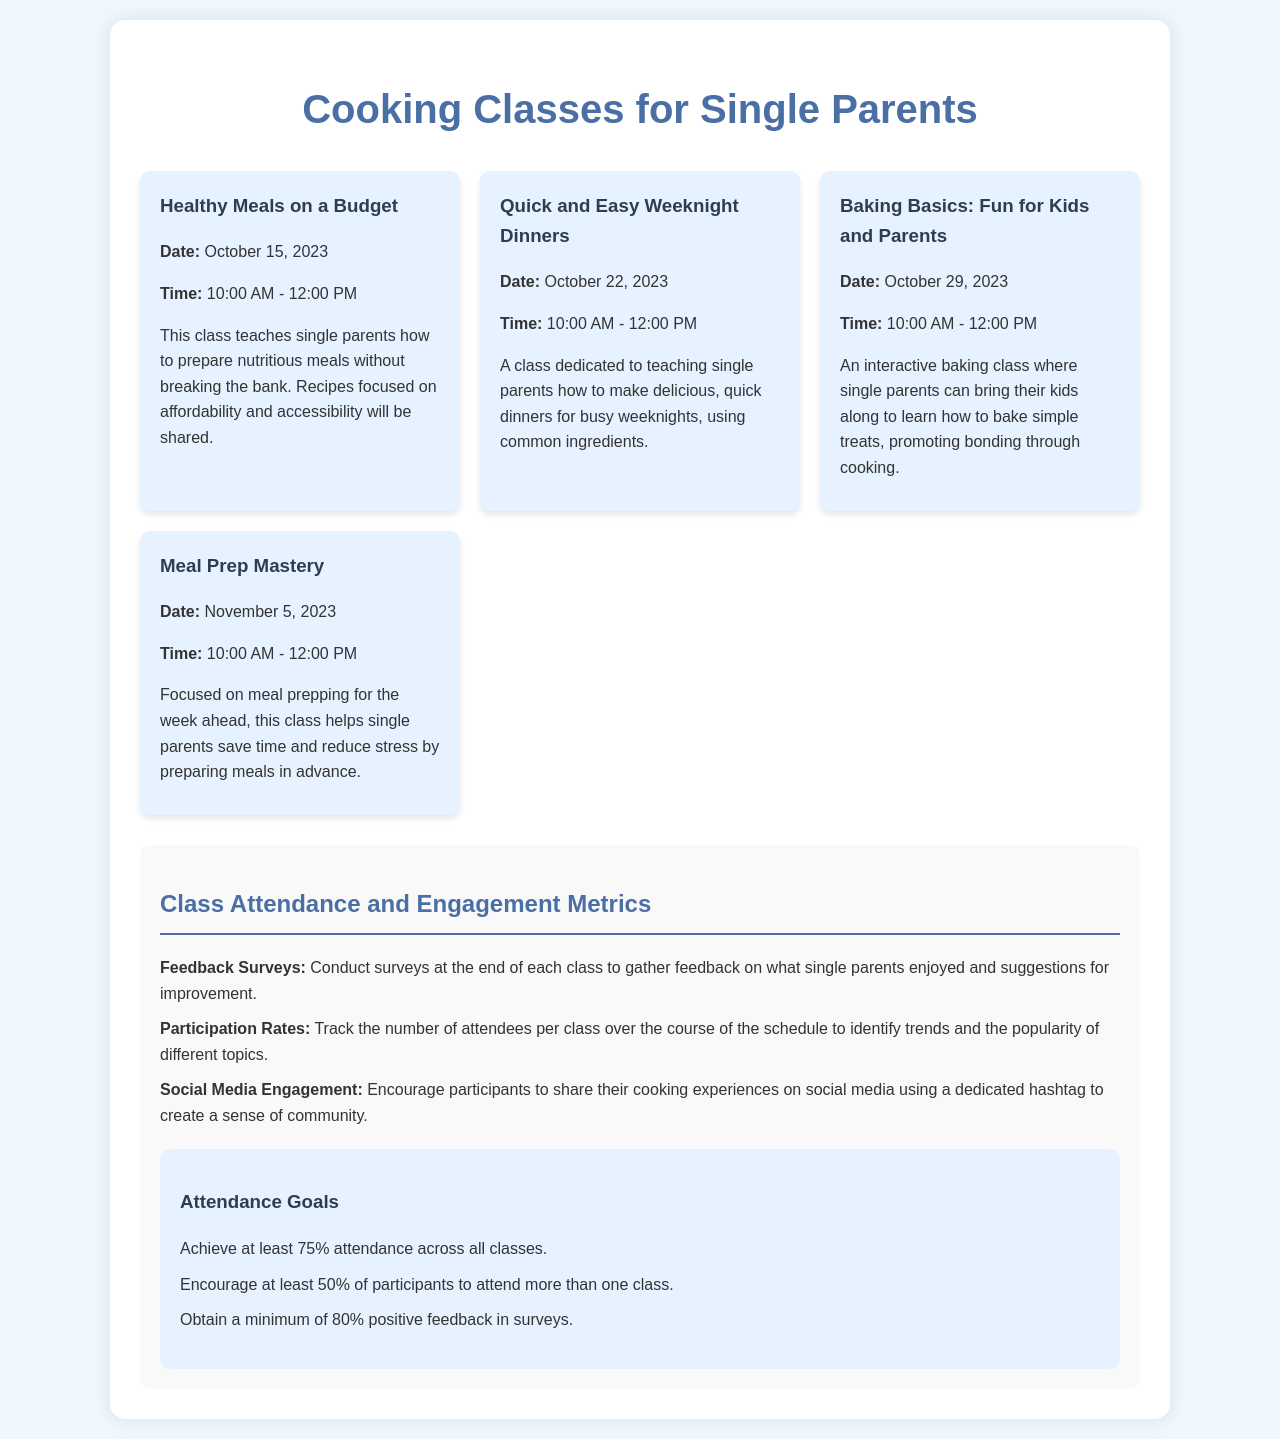What is the date of the first class? The first class is "Healthy Meals on a Budget," which is scheduled for October 15, 2023.
Answer: October 15, 2023 What class teaches quick weeknight dinners? The class dedicated to teaching quick dinners is titled "Quick and Easy Weeknight Dinners."
Answer: Quick and Easy Weeknight Dinners How long does each class last? Each class is scheduled for a duration from 10:00 AM to 12:00 PM, which is 2 hours.
Answer: 2 hours What is the minimum positive feedback percentage goal? The document specifies obtaining a minimum of 80% positive feedback in surveys as a goal.
Answer: 80% Which class focuses on meal prepping? The class that focuses on meal prepping is titled "Meal Prep Mastery."
Answer: Meal Prep Mastery What percentage of participants are encouraged to attend more than one class? The document states that at least 50% of participants are encouraged to attend more than one class.
Answer: 50% What is the feedback method mentioned? The document mentions conducting surveys at the end of each class for feedback.
Answer: Surveys How many classes are listed in the schedule? The schedule lists a total of four cooking classes for single parents.
Answer: Four 